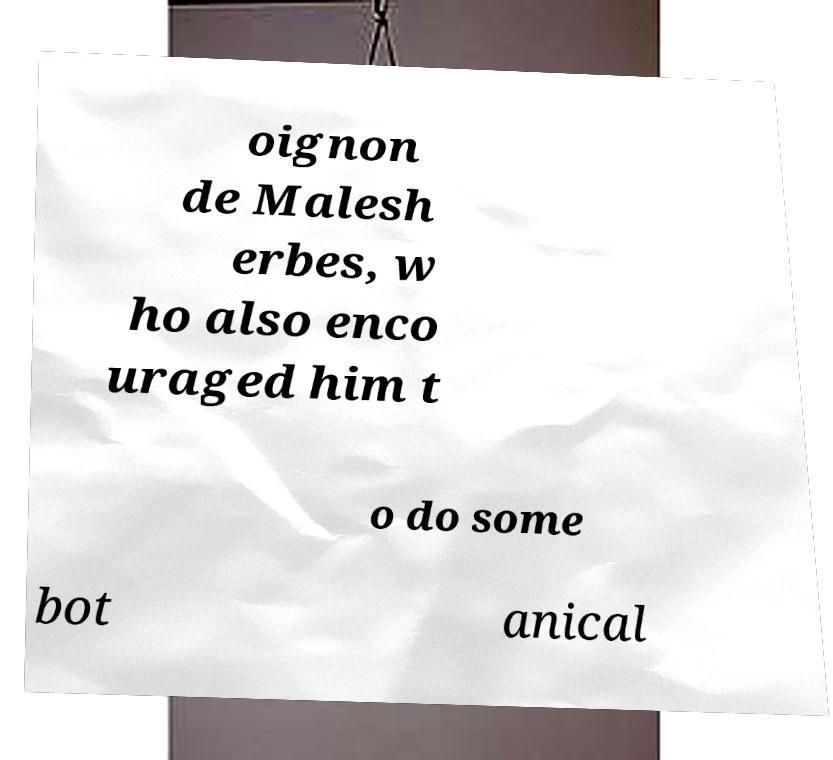There's text embedded in this image that I need extracted. Can you transcribe it verbatim? oignon de Malesh erbes, w ho also enco uraged him t o do some bot anical 